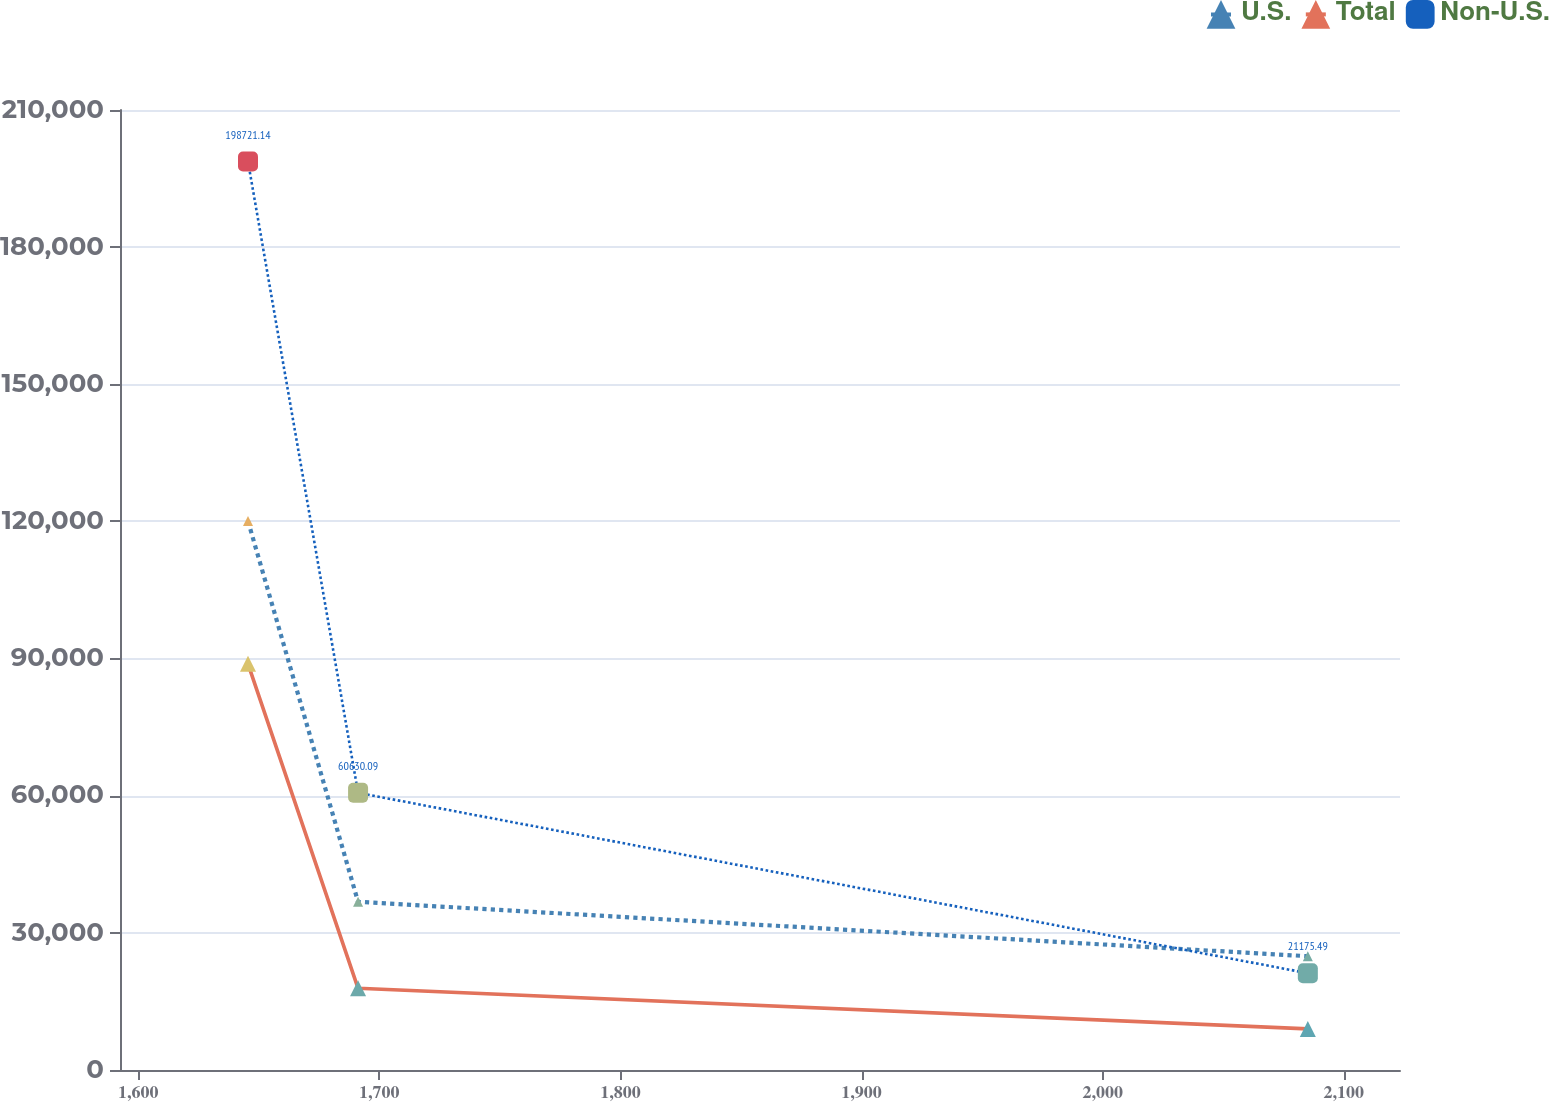Convert chart. <chart><loc_0><loc_0><loc_500><loc_500><line_chart><ecel><fcel>U.S.<fcel>Total<fcel>Non-U.S.<nl><fcel>1645.56<fcel>120071<fcel>88841.2<fcel>198721<nl><fcel>1691.21<fcel>36788.2<fcel>17867.1<fcel>60630.1<nl><fcel>2085.07<fcel>24890.7<fcel>8995.29<fcel>21175.5<nl><fcel>2130.72<fcel>12993.2<fcel>26738.8<fcel>40902.8<nl><fcel>2176.37<fcel>1095.74<fcel>123.52<fcel>1448.19<nl></chart> 